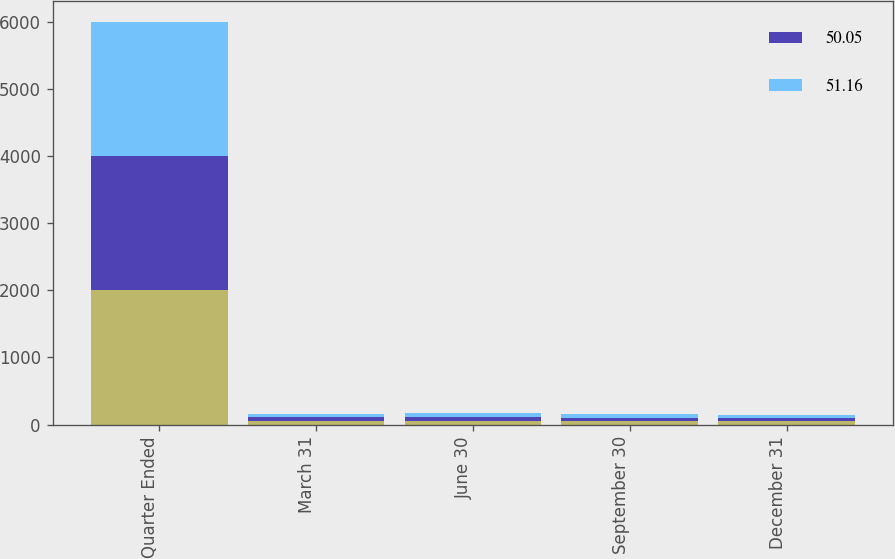Convert chart. <chart><loc_0><loc_0><loc_500><loc_500><stacked_bar_chart><ecel><fcel>Quarter Ended<fcel>March 31<fcel>June 30<fcel>September 30<fcel>December 31<nl><fcel>nan<fcel>2004<fcel>56.55<fcel>58.92<fcel>58.73<fcel>51.26<nl><fcel>50.05<fcel>2004<fcel>49.62<fcel>53.56<fcel>45.15<fcel>43.06<nl><fcel>51.16<fcel>2003<fcel>49.1<fcel>54.52<fcel>53.35<fcel>49.13<nl></chart> 